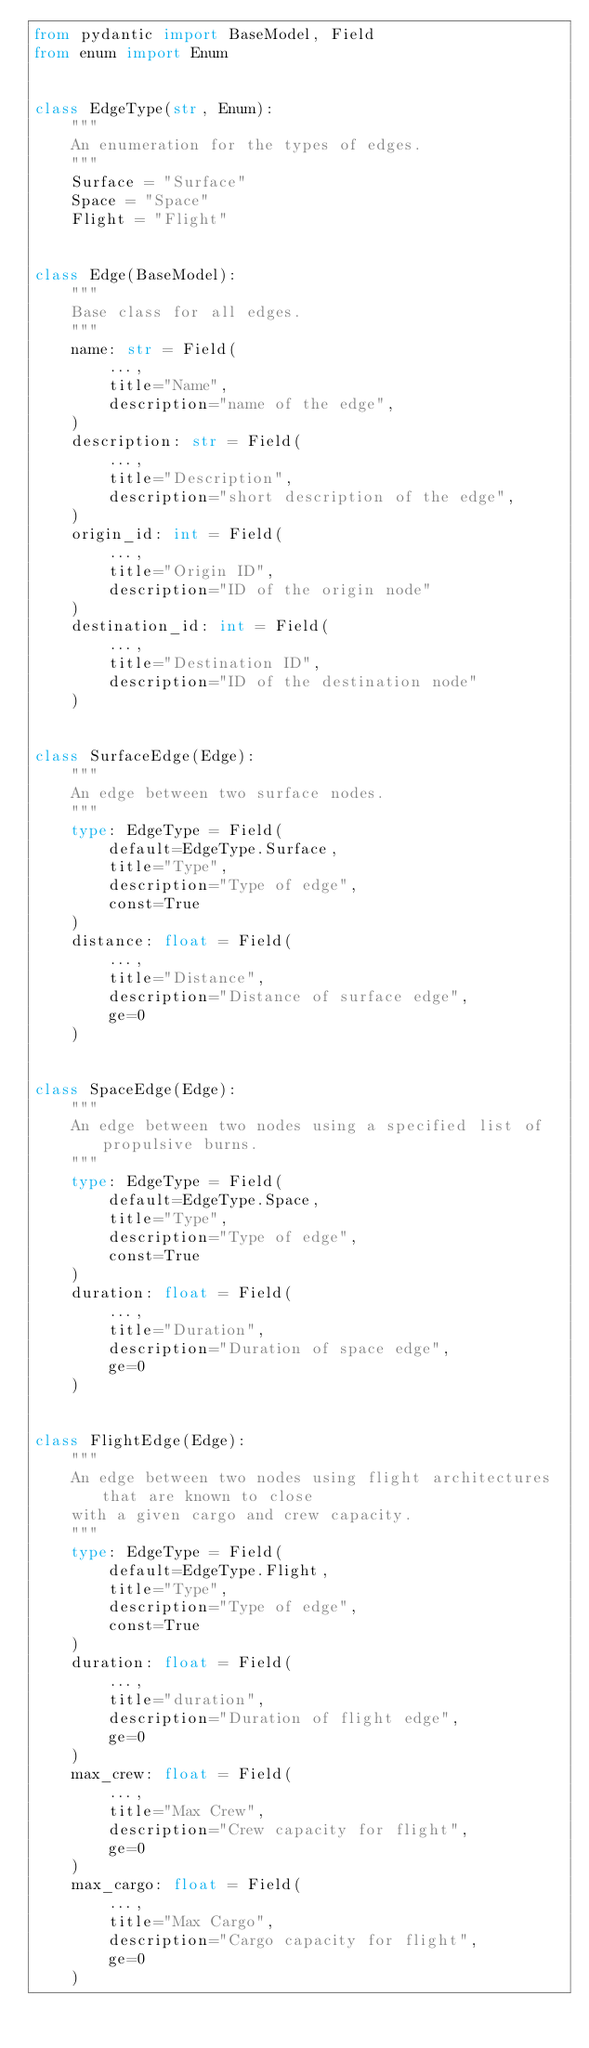<code> <loc_0><loc_0><loc_500><loc_500><_Python_>from pydantic import BaseModel, Field
from enum import Enum


class EdgeType(str, Enum):
    """
    An enumeration for the types of edges.
    """
    Surface = "Surface"
    Space = "Space"
    Flight = "Flight"


class Edge(BaseModel):
    """
    Base class for all edges.
    """
    name: str = Field(
        ...,
        title="Name",
        description="name of the edge",
    )
    description: str = Field(
        ...,
        title="Description",
        description="short description of the edge",
    )
    origin_id: int = Field(
        ...,
        title="Origin ID",
        description="ID of the origin node"
    )
    destination_id: int = Field(
        ...,
        title="Destination ID",
        description="ID of the destination node"
    )


class SurfaceEdge(Edge):
    """
    An edge between two surface nodes.
    """
    type: EdgeType = Field(
        default=EdgeType.Surface,
        title="Type",
        description="Type of edge",
        const=True
    )
    distance: float = Field(
        ...,
        title="Distance",
        description="Distance of surface edge",
        ge=0
    )


class SpaceEdge(Edge):
    """
    An edge between two nodes using a specified list of propulsive burns.
    """
    type: EdgeType = Field(
        default=EdgeType.Space,
        title="Type",
        description="Type of edge",
        const=True
    )
    duration: float = Field(
        ...,
        title="Duration",
        description="Duration of space edge",
        ge=0
    )


class FlightEdge(Edge):
    """
    An edge between two nodes using flight architectures that are known to close
    with a given cargo and crew capacity.
    """
    type: EdgeType = Field(
        default=EdgeType.Flight,
        title="Type",
        description="Type of edge",
        const=True
    )
    duration: float = Field(
        ...,
        title="duration",
        description="Duration of flight edge",
        ge=0
    )
    max_crew: float = Field(
        ...,
        title="Max Crew",
        description="Crew capacity for flight",
        ge=0
    )
    max_cargo: float = Field(
        ...,
        title="Max Cargo",
        description="Cargo capacity for flight",
        ge=0
    )

</code> 